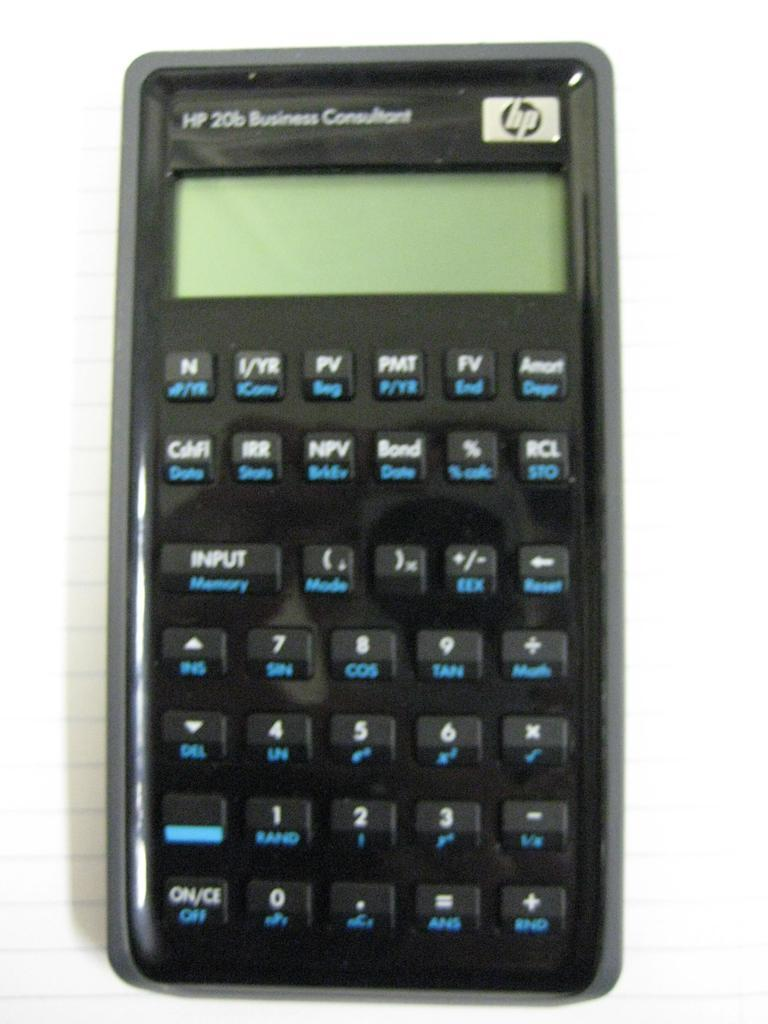<image>
Render a clear and concise summary of the photo. A Business Consultant black HP calculator is shown turned off. 